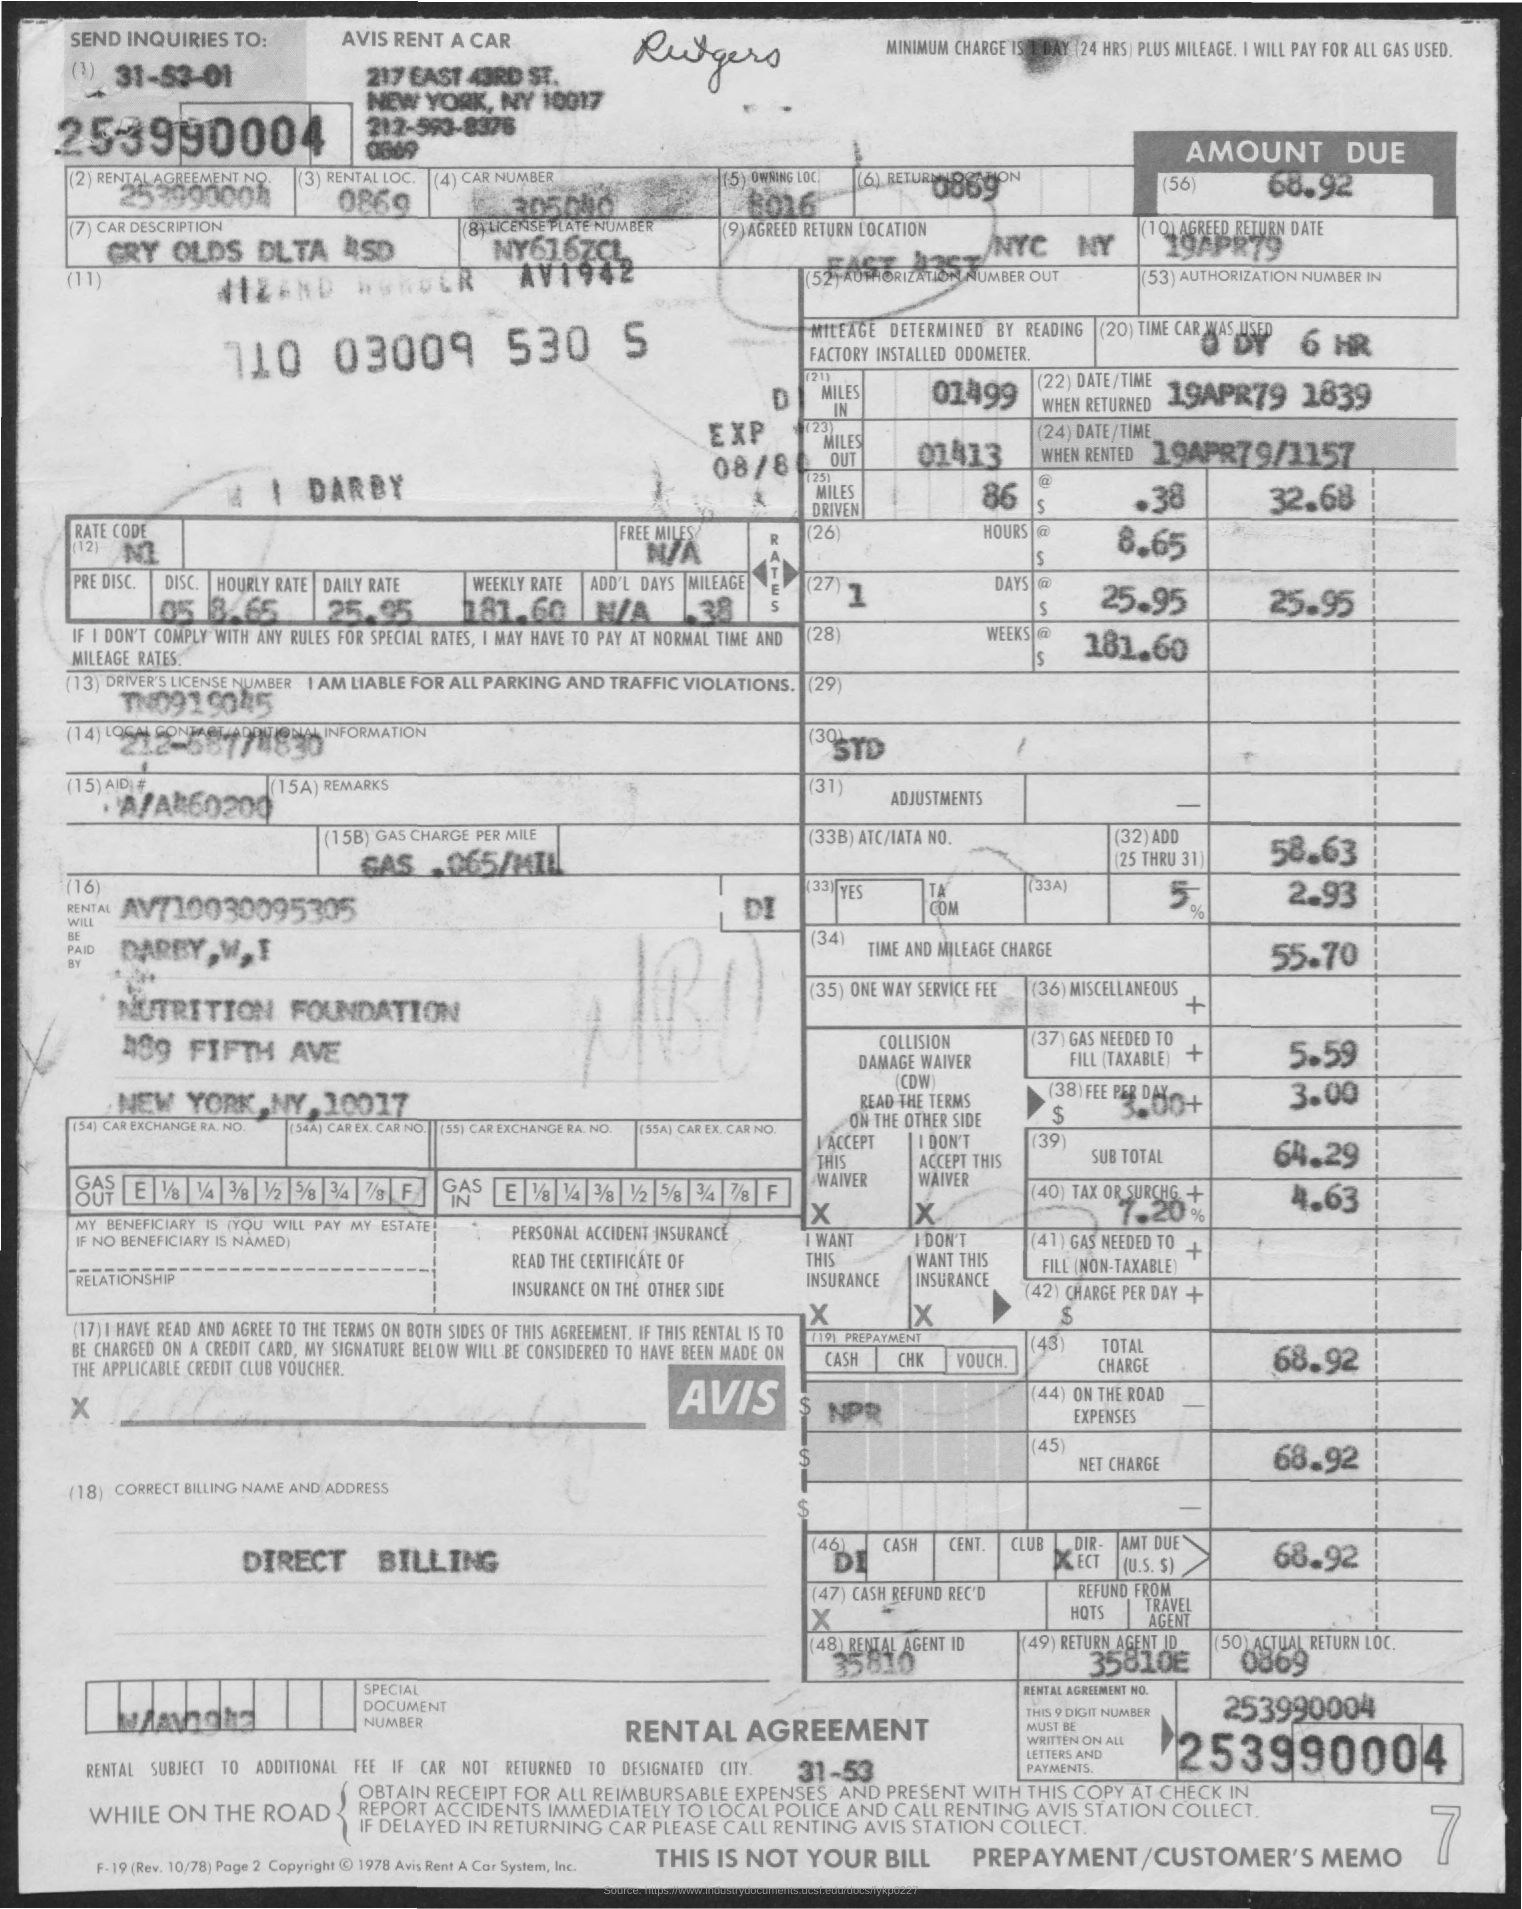Draw attention to some important aspects in this diagram. The rental agreement number is 253990004. 